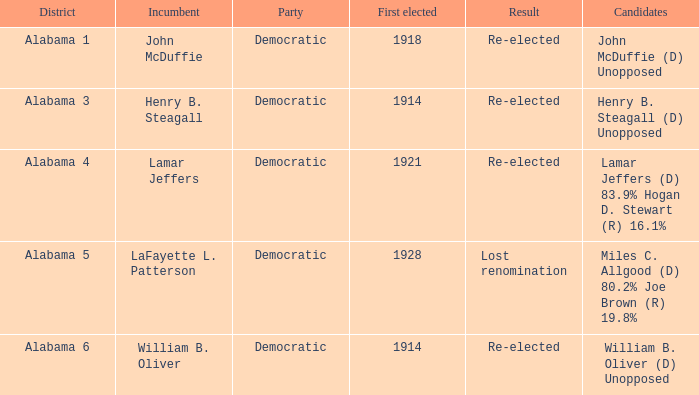Which political party is associated with alabama's district 1? Democratic. 